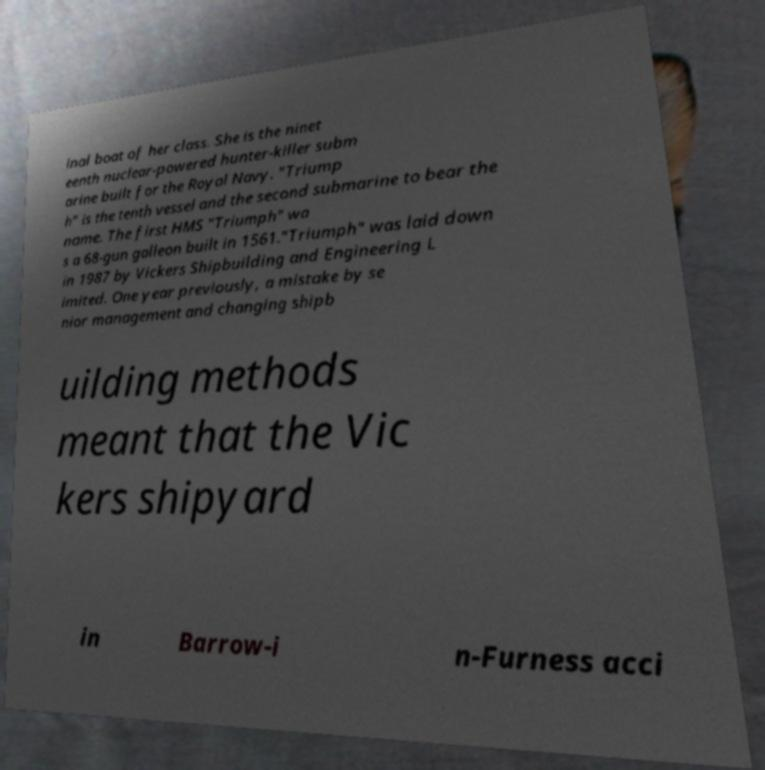Could you assist in decoding the text presented in this image and type it out clearly? inal boat of her class. She is the ninet eenth nuclear-powered hunter-killer subm arine built for the Royal Navy. "Triump h" is the tenth vessel and the second submarine to bear the name. The first HMS "Triumph" wa s a 68-gun galleon built in 1561."Triumph" was laid down in 1987 by Vickers Shipbuilding and Engineering L imited. One year previously, a mistake by se nior management and changing shipb uilding methods meant that the Vic kers shipyard in Barrow-i n-Furness acci 